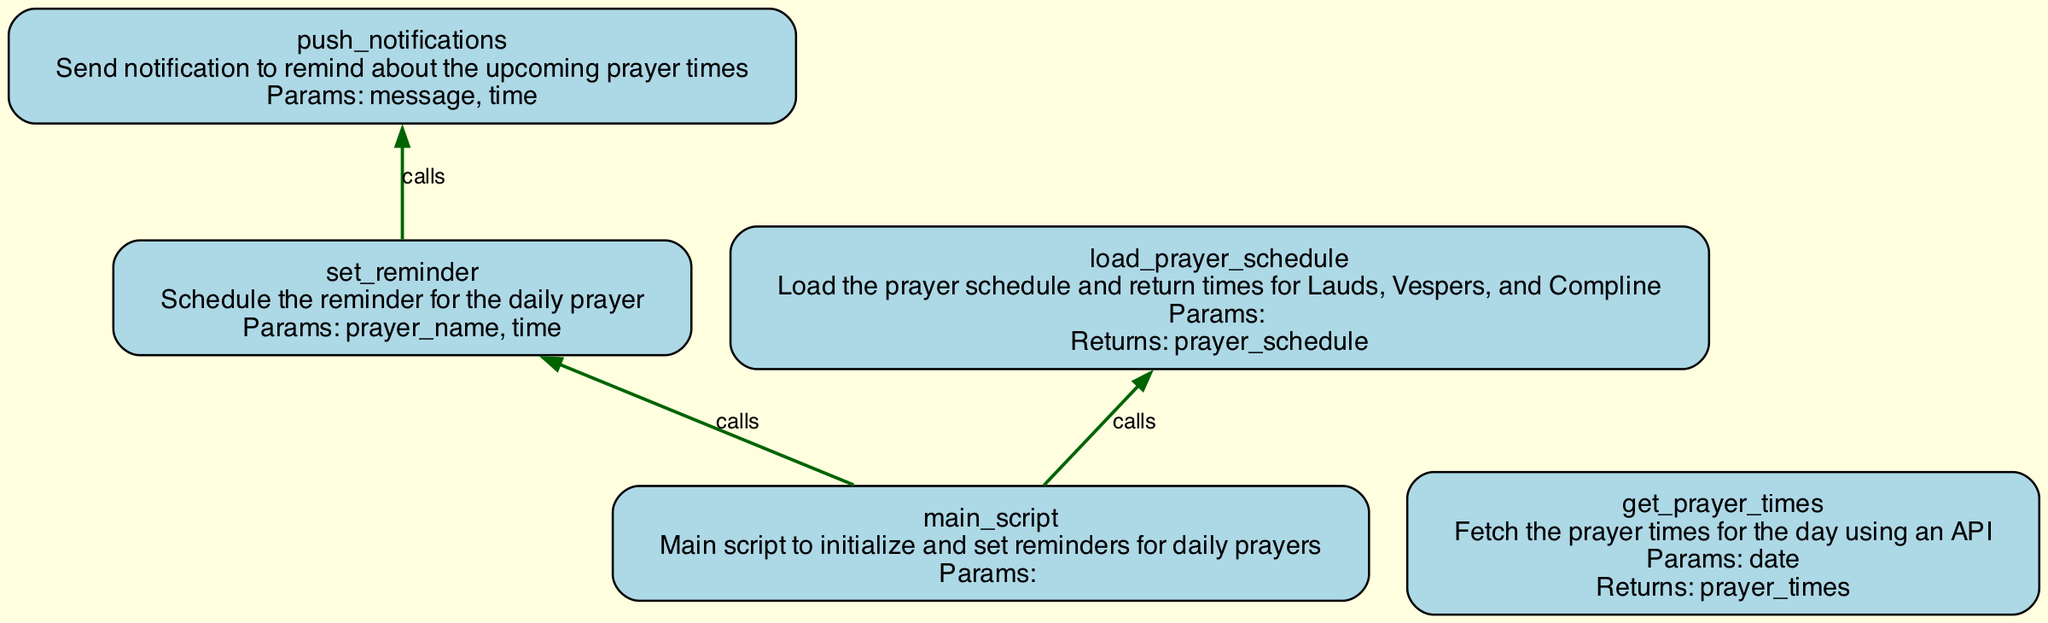what functions are defined in this diagram? The diagram depicts several functions related to a daily prayer routine. They include: push_notifications, set_reminder, get_prayer_times, load_prayer_schedule, and main_script.
Answer: push_notifications, set_reminder, get_prayer_times, load_prayer_schedule, main_script what is the purpose of the set_reminder function? The set_reminder function is designed to schedule reminders for the daily prayer, taking the prayer name and time as parameters.
Answer: Schedule reminders for the daily prayer how many parameters does the get_prayer_times function have? The get_prayer_times function has one parameter, which is 'date'. This is evident from the function's attributes section in the diagram.
Answer: one which function is called by the load_prayer_schedule function? The load_prayer_schedule function calls the get_prayer_times function, as indicated in the calls section of load_prayer_schedule.
Answer: get_prayer_times what will the main_script function do? The main_script function initializes and sets reminders for daily prayers by calling load_prayer_schedule and set_reminder functions.
Answer: Initialize and set reminders for daily prayers which function utilizes push_notifications? The set_reminder function utilizes push_notifications as indicated by the calls attribute in the diagram, signifying that set_reminder will call push_notifications upon execution.
Answer: set_reminder how does push_notifications relate to set_reminder? Push_notifications is called by the set_reminder function during its execution, indicating that when a reminder is set, a notification is pushed.
Answer: Push_notifications is called by set_reminder what is returned by the load_prayer_schedule function? The load_prayer_schedule function returns prayer_schedule, which is outlined in its attributes description section.
Answer: prayer_schedule 